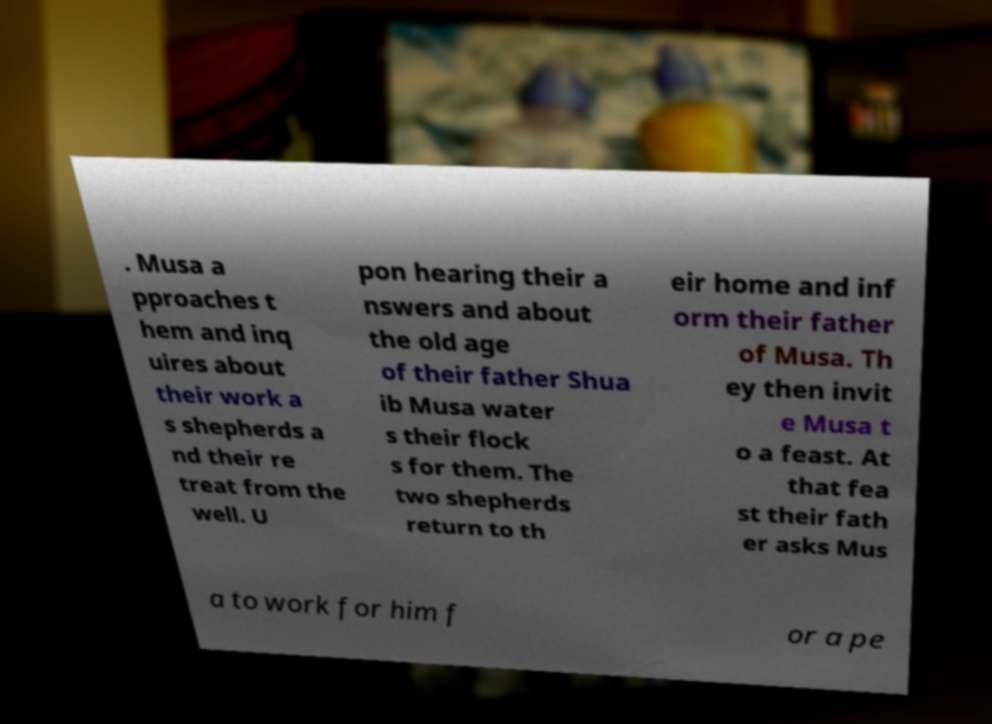Can you read and provide the text displayed in the image?This photo seems to have some interesting text. Can you extract and type it out for me? . Musa a pproaches t hem and inq uires about their work a s shepherds a nd their re treat from the well. U pon hearing their a nswers and about the old age of their father Shua ib Musa water s their flock s for them. The two shepherds return to th eir home and inf orm their father of Musa. Th ey then invit e Musa t o a feast. At that fea st their fath er asks Mus a to work for him f or a pe 